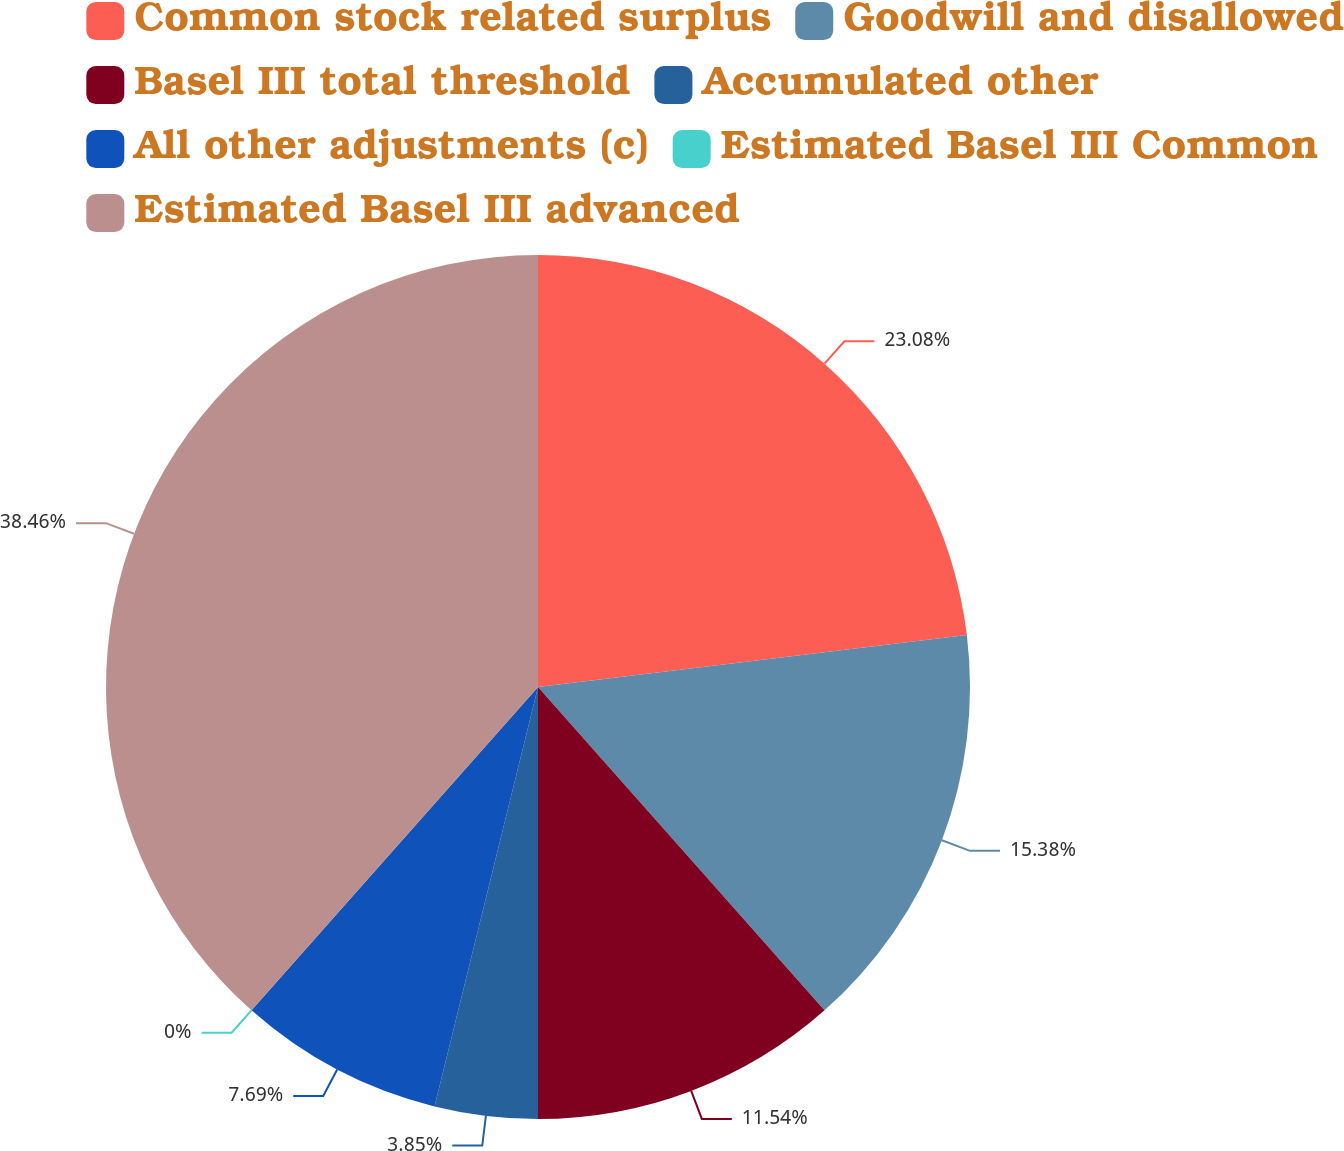Convert chart. <chart><loc_0><loc_0><loc_500><loc_500><pie_chart><fcel>Common stock related surplus<fcel>Goodwill and disallowed<fcel>Basel III total threshold<fcel>Accumulated other<fcel>All other adjustments (c)<fcel>Estimated Basel III Common<fcel>Estimated Basel III advanced<nl><fcel>23.08%<fcel>15.38%<fcel>11.54%<fcel>3.85%<fcel>7.69%<fcel>0.0%<fcel>38.46%<nl></chart> 